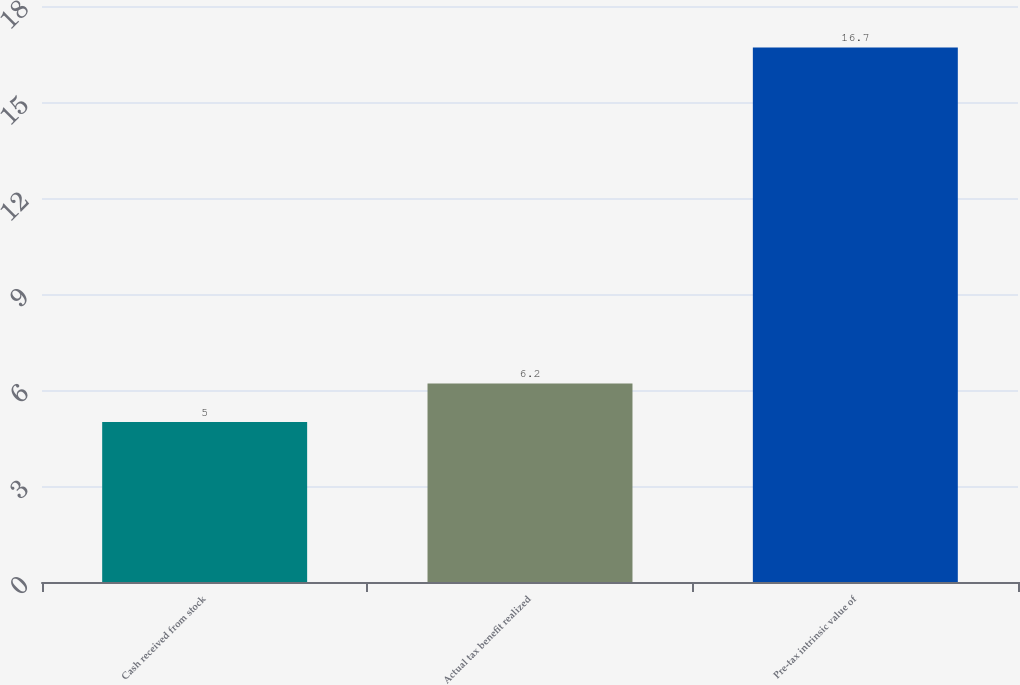<chart> <loc_0><loc_0><loc_500><loc_500><bar_chart><fcel>Cash received from stock<fcel>Actual tax benefit realized<fcel>Pre-tax intrinsic value of<nl><fcel>5<fcel>6.2<fcel>16.7<nl></chart> 